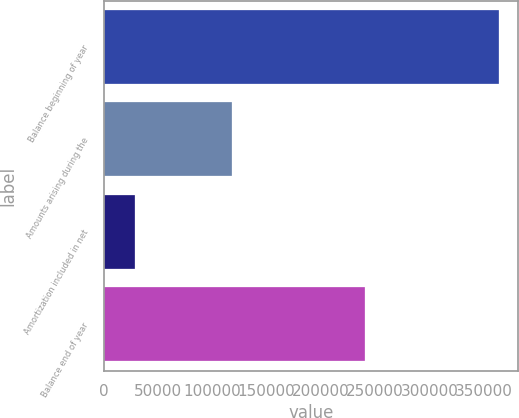Convert chart. <chart><loc_0><loc_0><loc_500><loc_500><bar_chart><fcel>Balance beginning of year<fcel>Amounts arising during the<fcel>Amortization included in net<fcel>Balance end of year<nl><fcel>363691<fcel>118666<fcel>29194<fcel>240345<nl></chart> 